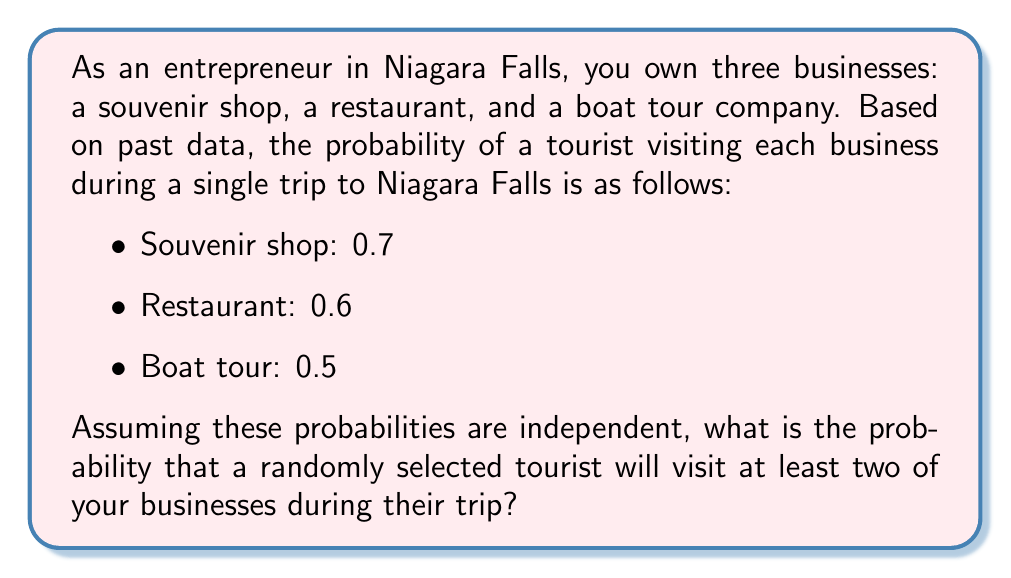Can you solve this math problem? To solve this problem, we'll use the concept of probability of complementary events. We'll calculate the probability of a tourist visiting fewer than two businesses (i.e., visiting none or just one) and subtract that from 1.

Let's define the events:
$S$: visit souvenir shop
$R$: visit restaurant
$B$: visit boat tour

Step 1: Calculate the probability of visiting no businesses
$$P(\text{no businesses}) = (1-0.7)(1-0.6)(1-0.5) = 0.3 \times 0.4 \times 0.5 = 0.06$$

Step 2: Calculate the probability of visiting exactly one business
$$\begin{align*}
P(\text{only } S) &= 0.7 \times 0.4 \times 0.5 = 0.14 \\
P(\text{only } R) &= 0.3 \times 0.6 \times 0.5 = 0.09 \\
P(\text{only } B) &= 0.3 \times 0.4 \times 0.5 = 0.06
\end{align*}$$

$$P(\text{exactly one business}) = 0.14 + 0.09 + 0.06 = 0.29$$

Step 3: Calculate the probability of visiting fewer than two businesses
$$P(\text{fewer than two}) = P(\text{no businesses}) + P(\text{exactly one business}) = 0.06 + 0.29 = 0.35$$

Step 4: Calculate the probability of visiting at least two businesses
$$P(\text{at least two}) = 1 - P(\text{fewer than two}) = 1 - 0.35 = 0.65$$
Answer: The probability that a randomly selected tourist will visit at least two of your businesses during their trip is $0.65$ or $65\%$. 